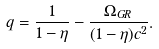Convert formula to latex. <formula><loc_0><loc_0><loc_500><loc_500>q = \frac { 1 } { 1 - \eta } - \frac { \Omega _ { G R } } { ( 1 - \eta ) c ^ { 2 } } .</formula> 